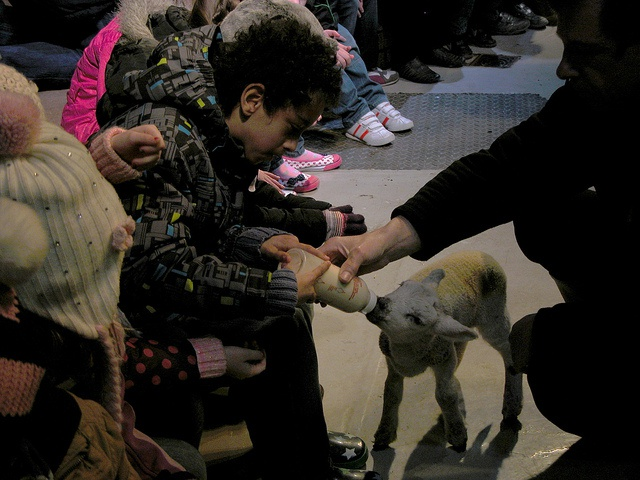Describe the objects in this image and their specific colors. I can see people in black and gray tones, people in black, gray, and maroon tones, people in black, gray, and olive tones, sheep in black, gray, and olive tones, and people in black, gray, and darkgray tones in this image. 